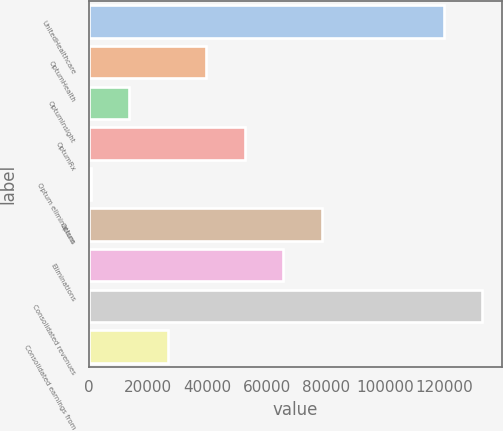<chart> <loc_0><loc_0><loc_500><loc_500><bar_chart><fcel>UnitedHealthcare<fcel>OptumHealth<fcel>OptumInsight<fcel>OptumRx<fcel>Optum eliminations<fcel>Optum<fcel>Eliminations<fcel>Consolidated revenues<fcel>Consolidated earnings from<nl><fcel>119798<fcel>39484.5<fcel>13487.5<fcel>52483<fcel>489<fcel>78480<fcel>65481.5<fcel>132796<fcel>26486<nl></chart> 